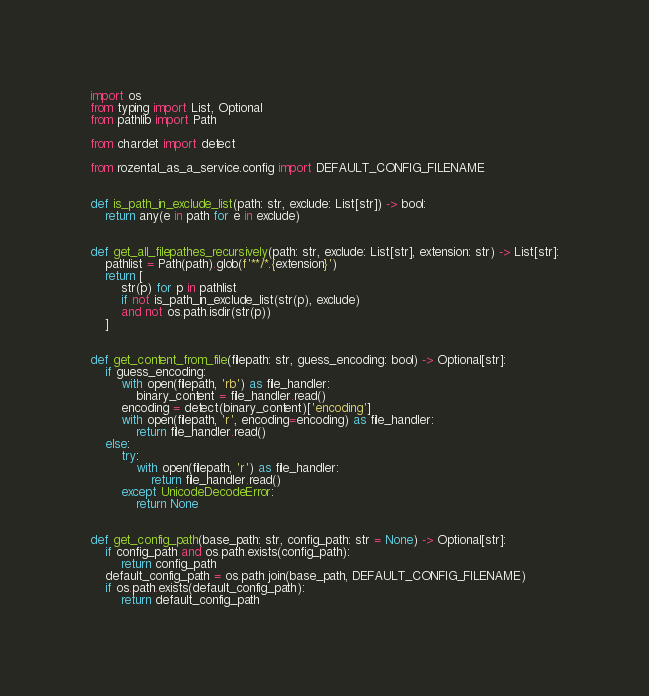<code> <loc_0><loc_0><loc_500><loc_500><_Python_>import os
from typing import List, Optional
from pathlib import Path

from chardet import detect

from rozental_as_a_service.config import DEFAULT_CONFIG_FILENAME


def is_path_in_exclude_list(path: str, exclude: List[str]) -> bool:
    return any(e in path for e in exclude)


def get_all_filepathes_recursively(path: str, exclude: List[str], extension: str) -> List[str]:
    pathlist = Path(path).glob(f'**/*.{extension}')
    return [
        str(p) for p in pathlist
        if not is_path_in_exclude_list(str(p), exclude)
        and not os.path.isdir(str(p))
    ]


def get_content_from_file(filepath: str, guess_encoding: bool) -> Optional[str]:
    if guess_encoding:
        with open(filepath, 'rb') as file_handler:
            binary_content = file_handler.read()
        encoding = detect(binary_content)['encoding']
        with open(filepath, 'r', encoding=encoding) as file_handler:
            return file_handler.read()
    else:
        try:
            with open(filepath, 'r') as file_handler:
                return file_handler.read()
        except UnicodeDecodeError:
            return None


def get_config_path(base_path: str, config_path: str = None) -> Optional[str]:
    if config_path and os.path.exists(config_path):
        return config_path
    default_config_path = os.path.join(base_path, DEFAULT_CONFIG_FILENAME)
    if os.path.exists(default_config_path):
        return default_config_path
</code> 